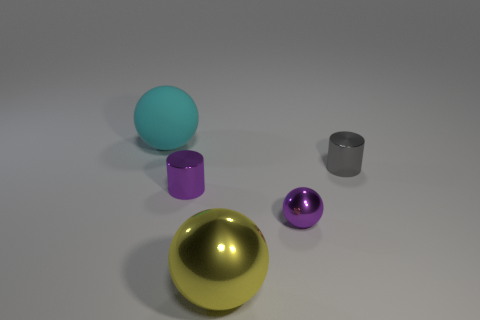Add 1 tiny gray metallic objects. How many objects exist? 6 Subtract all big balls. How many balls are left? 1 Subtract all balls. How many objects are left? 2 Subtract 3 balls. How many balls are left? 0 Subtract 0 gray spheres. How many objects are left? 5 Subtract all blue spheres. Subtract all red blocks. How many spheres are left? 3 Subtract all metal objects. Subtract all yellow metallic balls. How many objects are left? 0 Add 3 large yellow shiny things. How many large yellow shiny things are left? 4 Add 4 metallic objects. How many metallic objects exist? 8 Subtract all yellow balls. How many balls are left? 2 